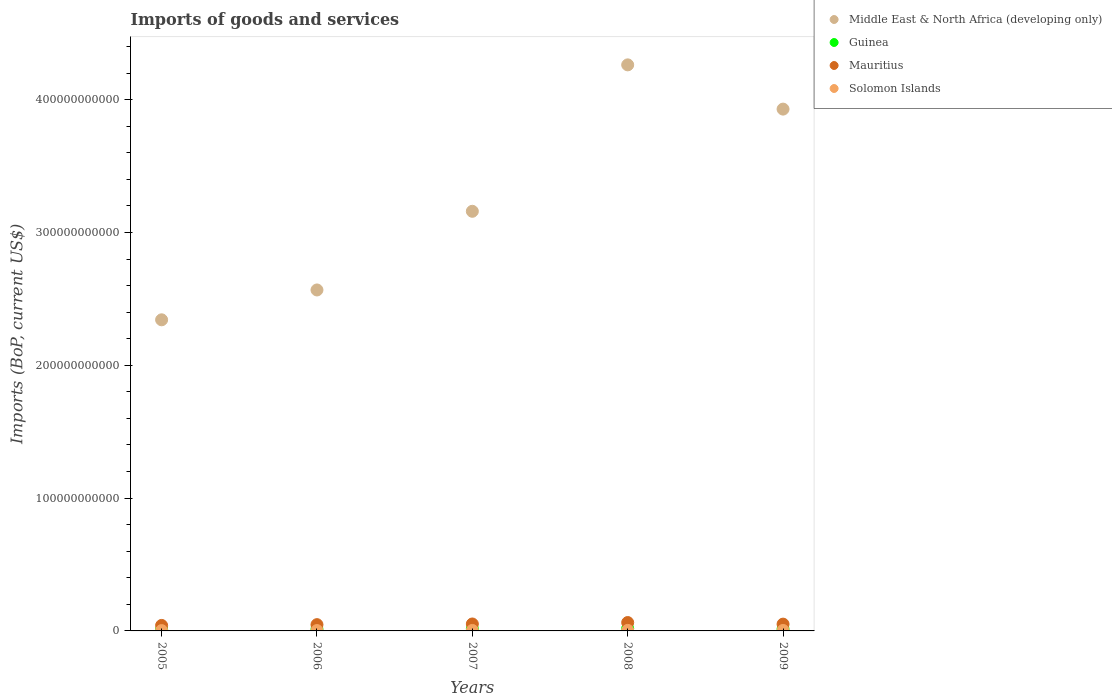How many different coloured dotlines are there?
Your response must be concise. 4. What is the amount spent on imports in Solomon Islands in 2009?
Provide a short and direct response. 3.44e+08. Across all years, what is the maximum amount spent on imports in Mauritius?
Your answer should be compact. 6.31e+09. Across all years, what is the minimum amount spent on imports in Middle East & North Africa (developing only)?
Your response must be concise. 2.34e+11. In which year was the amount spent on imports in Mauritius maximum?
Make the answer very short. 2008. What is the total amount spent on imports in Mauritius in the graph?
Give a very brief answer. 2.55e+1. What is the difference between the amount spent on imports in Guinea in 2005 and that in 2007?
Make the answer very short. -4.85e+08. What is the difference between the amount spent on imports in Mauritius in 2007 and the amount spent on imports in Solomon Islands in 2009?
Your answer should be very brief. 4.88e+09. What is the average amount spent on imports in Solomon Islands per year?
Offer a very short reply. 3.20e+08. In the year 2006, what is the difference between the amount spent on imports in Guinea and amount spent on imports in Solomon Islands?
Provide a succinct answer. 9.93e+08. In how many years, is the amount spent on imports in Mauritius greater than 160000000000 US$?
Keep it short and to the point. 0. What is the ratio of the amount spent on imports in Solomon Islands in 2007 to that in 2008?
Your answer should be compact. 0.91. Is the amount spent on imports in Middle East & North Africa (developing only) in 2006 less than that in 2007?
Give a very brief answer. Yes. What is the difference between the highest and the second highest amount spent on imports in Mauritius?
Make the answer very short. 1.08e+09. What is the difference between the highest and the lowest amount spent on imports in Guinea?
Ensure brevity in your answer.  7.83e+08. In how many years, is the amount spent on imports in Solomon Islands greater than the average amount spent on imports in Solomon Islands taken over all years?
Offer a terse response. 3. Is the sum of the amount spent on imports in Solomon Islands in 2005 and 2007 greater than the maximum amount spent on imports in Middle East & North Africa (developing only) across all years?
Your answer should be very brief. No. Is it the case that in every year, the sum of the amount spent on imports in Mauritius and amount spent on imports in Guinea  is greater than the sum of amount spent on imports in Middle East & North Africa (developing only) and amount spent on imports in Solomon Islands?
Your answer should be very brief. Yes. Does the amount spent on imports in Guinea monotonically increase over the years?
Offer a very short reply. No. How many dotlines are there?
Give a very brief answer. 4. What is the difference between two consecutive major ticks on the Y-axis?
Your answer should be compact. 1.00e+11. Are the values on the major ticks of Y-axis written in scientific E-notation?
Ensure brevity in your answer.  No. Does the graph contain any zero values?
Offer a terse response. No. What is the title of the graph?
Give a very brief answer. Imports of goods and services. What is the label or title of the Y-axis?
Your answer should be compact. Imports (BoP, current US$). What is the Imports (BoP, current US$) of Middle East & North Africa (developing only) in 2005?
Offer a terse response. 2.34e+11. What is the Imports (BoP, current US$) in Guinea in 2005?
Keep it short and to the point. 1.03e+09. What is the Imports (BoP, current US$) in Mauritius in 2005?
Your answer should be very brief. 4.13e+09. What is the Imports (BoP, current US$) of Solomon Islands in 2005?
Provide a succinct answer. 2.43e+08. What is the Imports (BoP, current US$) of Middle East & North Africa (developing only) in 2006?
Keep it short and to the point. 2.57e+11. What is the Imports (BoP, current US$) of Guinea in 2006?
Provide a succinct answer. 1.26e+09. What is the Imports (BoP, current US$) in Mauritius in 2006?
Make the answer very short. 4.73e+09. What is the Imports (BoP, current US$) of Solomon Islands in 2006?
Give a very brief answer. 2.63e+08. What is the Imports (BoP, current US$) of Middle East & North Africa (developing only) in 2007?
Offer a terse response. 3.16e+11. What is the Imports (BoP, current US$) of Guinea in 2007?
Offer a very short reply. 1.51e+09. What is the Imports (BoP, current US$) in Mauritius in 2007?
Provide a short and direct response. 5.23e+09. What is the Imports (BoP, current US$) of Solomon Islands in 2007?
Offer a terse response. 3.58e+08. What is the Imports (BoP, current US$) of Middle East & North Africa (developing only) in 2008?
Your answer should be very brief. 4.26e+11. What is the Imports (BoP, current US$) in Guinea in 2008?
Your answer should be very brief. 1.81e+09. What is the Imports (BoP, current US$) in Mauritius in 2008?
Give a very brief answer. 6.31e+09. What is the Imports (BoP, current US$) of Solomon Islands in 2008?
Make the answer very short. 3.93e+08. What is the Imports (BoP, current US$) in Middle East & North Africa (developing only) in 2009?
Your answer should be compact. 3.93e+11. What is the Imports (BoP, current US$) of Guinea in 2009?
Provide a succinct answer. 1.39e+09. What is the Imports (BoP, current US$) of Mauritius in 2009?
Provide a short and direct response. 5.11e+09. What is the Imports (BoP, current US$) of Solomon Islands in 2009?
Your answer should be very brief. 3.44e+08. Across all years, what is the maximum Imports (BoP, current US$) of Middle East & North Africa (developing only)?
Your response must be concise. 4.26e+11. Across all years, what is the maximum Imports (BoP, current US$) of Guinea?
Keep it short and to the point. 1.81e+09. Across all years, what is the maximum Imports (BoP, current US$) of Mauritius?
Make the answer very short. 6.31e+09. Across all years, what is the maximum Imports (BoP, current US$) of Solomon Islands?
Ensure brevity in your answer.  3.93e+08. Across all years, what is the minimum Imports (BoP, current US$) of Middle East & North Africa (developing only)?
Keep it short and to the point. 2.34e+11. Across all years, what is the minimum Imports (BoP, current US$) in Guinea?
Ensure brevity in your answer.  1.03e+09. Across all years, what is the minimum Imports (BoP, current US$) of Mauritius?
Provide a short and direct response. 4.13e+09. Across all years, what is the minimum Imports (BoP, current US$) of Solomon Islands?
Keep it short and to the point. 2.43e+08. What is the total Imports (BoP, current US$) in Middle East & North Africa (developing only) in the graph?
Keep it short and to the point. 1.63e+12. What is the total Imports (BoP, current US$) in Guinea in the graph?
Offer a terse response. 7.00e+09. What is the total Imports (BoP, current US$) of Mauritius in the graph?
Keep it short and to the point. 2.55e+1. What is the total Imports (BoP, current US$) in Solomon Islands in the graph?
Ensure brevity in your answer.  1.60e+09. What is the difference between the Imports (BoP, current US$) of Middle East & North Africa (developing only) in 2005 and that in 2006?
Your answer should be very brief. -2.25e+1. What is the difference between the Imports (BoP, current US$) in Guinea in 2005 and that in 2006?
Provide a short and direct response. -2.28e+08. What is the difference between the Imports (BoP, current US$) of Mauritius in 2005 and that in 2006?
Provide a short and direct response. -5.93e+08. What is the difference between the Imports (BoP, current US$) of Solomon Islands in 2005 and that in 2006?
Give a very brief answer. -2.03e+07. What is the difference between the Imports (BoP, current US$) of Middle East & North Africa (developing only) in 2005 and that in 2007?
Offer a terse response. -8.17e+1. What is the difference between the Imports (BoP, current US$) in Guinea in 2005 and that in 2007?
Provide a succinct answer. -4.85e+08. What is the difference between the Imports (BoP, current US$) in Mauritius in 2005 and that in 2007?
Ensure brevity in your answer.  -1.09e+09. What is the difference between the Imports (BoP, current US$) of Solomon Islands in 2005 and that in 2007?
Your answer should be very brief. -1.15e+08. What is the difference between the Imports (BoP, current US$) in Middle East & North Africa (developing only) in 2005 and that in 2008?
Give a very brief answer. -1.92e+11. What is the difference between the Imports (BoP, current US$) in Guinea in 2005 and that in 2008?
Provide a short and direct response. -7.83e+08. What is the difference between the Imports (BoP, current US$) in Mauritius in 2005 and that in 2008?
Offer a very short reply. -2.17e+09. What is the difference between the Imports (BoP, current US$) of Solomon Islands in 2005 and that in 2008?
Provide a short and direct response. -1.50e+08. What is the difference between the Imports (BoP, current US$) in Middle East & North Africa (developing only) in 2005 and that in 2009?
Provide a succinct answer. -1.59e+11. What is the difference between the Imports (BoP, current US$) of Guinea in 2005 and that in 2009?
Provide a short and direct response. -3.63e+08. What is the difference between the Imports (BoP, current US$) in Mauritius in 2005 and that in 2009?
Provide a short and direct response. -9.78e+08. What is the difference between the Imports (BoP, current US$) in Solomon Islands in 2005 and that in 2009?
Offer a very short reply. -1.01e+08. What is the difference between the Imports (BoP, current US$) of Middle East & North Africa (developing only) in 2006 and that in 2007?
Provide a succinct answer. -5.92e+1. What is the difference between the Imports (BoP, current US$) in Guinea in 2006 and that in 2007?
Make the answer very short. -2.57e+08. What is the difference between the Imports (BoP, current US$) of Mauritius in 2006 and that in 2007?
Keep it short and to the point. -4.99e+08. What is the difference between the Imports (BoP, current US$) in Solomon Islands in 2006 and that in 2007?
Your answer should be compact. -9.44e+07. What is the difference between the Imports (BoP, current US$) of Middle East & North Africa (developing only) in 2006 and that in 2008?
Keep it short and to the point. -1.69e+11. What is the difference between the Imports (BoP, current US$) of Guinea in 2006 and that in 2008?
Your response must be concise. -5.54e+08. What is the difference between the Imports (BoP, current US$) of Mauritius in 2006 and that in 2008?
Your answer should be compact. -1.58e+09. What is the difference between the Imports (BoP, current US$) of Solomon Islands in 2006 and that in 2008?
Your answer should be compact. -1.29e+08. What is the difference between the Imports (BoP, current US$) of Middle East & North Africa (developing only) in 2006 and that in 2009?
Provide a short and direct response. -1.36e+11. What is the difference between the Imports (BoP, current US$) in Guinea in 2006 and that in 2009?
Offer a terse response. -1.35e+08. What is the difference between the Imports (BoP, current US$) in Mauritius in 2006 and that in 2009?
Give a very brief answer. -3.86e+08. What is the difference between the Imports (BoP, current US$) in Solomon Islands in 2006 and that in 2009?
Your response must be concise. -8.06e+07. What is the difference between the Imports (BoP, current US$) in Middle East & North Africa (developing only) in 2007 and that in 2008?
Your response must be concise. -1.10e+11. What is the difference between the Imports (BoP, current US$) of Guinea in 2007 and that in 2008?
Provide a short and direct response. -2.98e+08. What is the difference between the Imports (BoP, current US$) in Mauritius in 2007 and that in 2008?
Your answer should be compact. -1.08e+09. What is the difference between the Imports (BoP, current US$) of Solomon Islands in 2007 and that in 2008?
Give a very brief answer. -3.50e+07. What is the difference between the Imports (BoP, current US$) of Middle East & North Africa (developing only) in 2007 and that in 2009?
Keep it short and to the point. -7.69e+1. What is the difference between the Imports (BoP, current US$) of Guinea in 2007 and that in 2009?
Make the answer very short. 1.22e+08. What is the difference between the Imports (BoP, current US$) in Mauritius in 2007 and that in 2009?
Offer a very short reply. 1.14e+08. What is the difference between the Imports (BoP, current US$) in Solomon Islands in 2007 and that in 2009?
Ensure brevity in your answer.  1.37e+07. What is the difference between the Imports (BoP, current US$) in Middle East & North Africa (developing only) in 2008 and that in 2009?
Give a very brief answer. 3.33e+1. What is the difference between the Imports (BoP, current US$) of Guinea in 2008 and that in 2009?
Make the answer very short. 4.20e+08. What is the difference between the Imports (BoP, current US$) of Mauritius in 2008 and that in 2009?
Ensure brevity in your answer.  1.19e+09. What is the difference between the Imports (BoP, current US$) in Solomon Islands in 2008 and that in 2009?
Ensure brevity in your answer.  4.87e+07. What is the difference between the Imports (BoP, current US$) of Middle East & North Africa (developing only) in 2005 and the Imports (BoP, current US$) of Guinea in 2006?
Give a very brief answer. 2.33e+11. What is the difference between the Imports (BoP, current US$) of Middle East & North Africa (developing only) in 2005 and the Imports (BoP, current US$) of Mauritius in 2006?
Keep it short and to the point. 2.30e+11. What is the difference between the Imports (BoP, current US$) in Middle East & North Africa (developing only) in 2005 and the Imports (BoP, current US$) in Solomon Islands in 2006?
Your answer should be compact. 2.34e+11. What is the difference between the Imports (BoP, current US$) in Guinea in 2005 and the Imports (BoP, current US$) in Mauritius in 2006?
Your answer should be compact. -3.70e+09. What is the difference between the Imports (BoP, current US$) of Guinea in 2005 and the Imports (BoP, current US$) of Solomon Islands in 2006?
Your answer should be compact. 7.64e+08. What is the difference between the Imports (BoP, current US$) in Mauritius in 2005 and the Imports (BoP, current US$) in Solomon Islands in 2006?
Provide a short and direct response. 3.87e+09. What is the difference between the Imports (BoP, current US$) of Middle East & North Africa (developing only) in 2005 and the Imports (BoP, current US$) of Guinea in 2007?
Your answer should be compact. 2.33e+11. What is the difference between the Imports (BoP, current US$) in Middle East & North Africa (developing only) in 2005 and the Imports (BoP, current US$) in Mauritius in 2007?
Provide a short and direct response. 2.29e+11. What is the difference between the Imports (BoP, current US$) in Middle East & North Africa (developing only) in 2005 and the Imports (BoP, current US$) in Solomon Islands in 2007?
Provide a short and direct response. 2.34e+11. What is the difference between the Imports (BoP, current US$) in Guinea in 2005 and the Imports (BoP, current US$) in Mauritius in 2007?
Give a very brief answer. -4.20e+09. What is the difference between the Imports (BoP, current US$) of Guinea in 2005 and the Imports (BoP, current US$) of Solomon Islands in 2007?
Make the answer very short. 6.70e+08. What is the difference between the Imports (BoP, current US$) in Mauritius in 2005 and the Imports (BoP, current US$) in Solomon Islands in 2007?
Give a very brief answer. 3.78e+09. What is the difference between the Imports (BoP, current US$) in Middle East & North Africa (developing only) in 2005 and the Imports (BoP, current US$) in Guinea in 2008?
Offer a very short reply. 2.32e+11. What is the difference between the Imports (BoP, current US$) of Middle East & North Africa (developing only) in 2005 and the Imports (BoP, current US$) of Mauritius in 2008?
Give a very brief answer. 2.28e+11. What is the difference between the Imports (BoP, current US$) of Middle East & North Africa (developing only) in 2005 and the Imports (BoP, current US$) of Solomon Islands in 2008?
Ensure brevity in your answer.  2.34e+11. What is the difference between the Imports (BoP, current US$) in Guinea in 2005 and the Imports (BoP, current US$) in Mauritius in 2008?
Your answer should be compact. -5.28e+09. What is the difference between the Imports (BoP, current US$) of Guinea in 2005 and the Imports (BoP, current US$) of Solomon Islands in 2008?
Make the answer very short. 6.35e+08. What is the difference between the Imports (BoP, current US$) in Mauritius in 2005 and the Imports (BoP, current US$) in Solomon Islands in 2008?
Give a very brief answer. 3.74e+09. What is the difference between the Imports (BoP, current US$) of Middle East & North Africa (developing only) in 2005 and the Imports (BoP, current US$) of Guinea in 2009?
Your answer should be compact. 2.33e+11. What is the difference between the Imports (BoP, current US$) in Middle East & North Africa (developing only) in 2005 and the Imports (BoP, current US$) in Mauritius in 2009?
Your response must be concise. 2.29e+11. What is the difference between the Imports (BoP, current US$) of Middle East & North Africa (developing only) in 2005 and the Imports (BoP, current US$) of Solomon Islands in 2009?
Your answer should be compact. 2.34e+11. What is the difference between the Imports (BoP, current US$) in Guinea in 2005 and the Imports (BoP, current US$) in Mauritius in 2009?
Your answer should be compact. -4.08e+09. What is the difference between the Imports (BoP, current US$) of Guinea in 2005 and the Imports (BoP, current US$) of Solomon Islands in 2009?
Keep it short and to the point. 6.84e+08. What is the difference between the Imports (BoP, current US$) in Mauritius in 2005 and the Imports (BoP, current US$) in Solomon Islands in 2009?
Your answer should be compact. 3.79e+09. What is the difference between the Imports (BoP, current US$) in Middle East & North Africa (developing only) in 2006 and the Imports (BoP, current US$) in Guinea in 2007?
Provide a succinct answer. 2.55e+11. What is the difference between the Imports (BoP, current US$) of Middle East & North Africa (developing only) in 2006 and the Imports (BoP, current US$) of Mauritius in 2007?
Your answer should be very brief. 2.52e+11. What is the difference between the Imports (BoP, current US$) of Middle East & North Africa (developing only) in 2006 and the Imports (BoP, current US$) of Solomon Islands in 2007?
Offer a very short reply. 2.56e+11. What is the difference between the Imports (BoP, current US$) of Guinea in 2006 and the Imports (BoP, current US$) of Mauritius in 2007?
Keep it short and to the point. -3.97e+09. What is the difference between the Imports (BoP, current US$) in Guinea in 2006 and the Imports (BoP, current US$) in Solomon Islands in 2007?
Provide a succinct answer. 8.98e+08. What is the difference between the Imports (BoP, current US$) in Mauritius in 2006 and the Imports (BoP, current US$) in Solomon Islands in 2007?
Your answer should be very brief. 4.37e+09. What is the difference between the Imports (BoP, current US$) of Middle East & North Africa (developing only) in 2006 and the Imports (BoP, current US$) of Guinea in 2008?
Make the answer very short. 2.55e+11. What is the difference between the Imports (BoP, current US$) in Middle East & North Africa (developing only) in 2006 and the Imports (BoP, current US$) in Mauritius in 2008?
Your answer should be compact. 2.50e+11. What is the difference between the Imports (BoP, current US$) of Middle East & North Africa (developing only) in 2006 and the Imports (BoP, current US$) of Solomon Islands in 2008?
Offer a very short reply. 2.56e+11. What is the difference between the Imports (BoP, current US$) of Guinea in 2006 and the Imports (BoP, current US$) of Mauritius in 2008?
Keep it short and to the point. -5.05e+09. What is the difference between the Imports (BoP, current US$) of Guinea in 2006 and the Imports (BoP, current US$) of Solomon Islands in 2008?
Provide a succinct answer. 8.63e+08. What is the difference between the Imports (BoP, current US$) in Mauritius in 2006 and the Imports (BoP, current US$) in Solomon Islands in 2008?
Make the answer very short. 4.33e+09. What is the difference between the Imports (BoP, current US$) of Middle East & North Africa (developing only) in 2006 and the Imports (BoP, current US$) of Guinea in 2009?
Keep it short and to the point. 2.55e+11. What is the difference between the Imports (BoP, current US$) in Middle East & North Africa (developing only) in 2006 and the Imports (BoP, current US$) in Mauritius in 2009?
Your answer should be compact. 2.52e+11. What is the difference between the Imports (BoP, current US$) in Middle East & North Africa (developing only) in 2006 and the Imports (BoP, current US$) in Solomon Islands in 2009?
Make the answer very short. 2.56e+11. What is the difference between the Imports (BoP, current US$) in Guinea in 2006 and the Imports (BoP, current US$) in Mauritius in 2009?
Provide a succinct answer. -3.86e+09. What is the difference between the Imports (BoP, current US$) in Guinea in 2006 and the Imports (BoP, current US$) in Solomon Islands in 2009?
Give a very brief answer. 9.12e+08. What is the difference between the Imports (BoP, current US$) in Mauritius in 2006 and the Imports (BoP, current US$) in Solomon Islands in 2009?
Provide a succinct answer. 4.38e+09. What is the difference between the Imports (BoP, current US$) in Middle East & North Africa (developing only) in 2007 and the Imports (BoP, current US$) in Guinea in 2008?
Offer a very short reply. 3.14e+11. What is the difference between the Imports (BoP, current US$) of Middle East & North Africa (developing only) in 2007 and the Imports (BoP, current US$) of Mauritius in 2008?
Provide a succinct answer. 3.10e+11. What is the difference between the Imports (BoP, current US$) of Middle East & North Africa (developing only) in 2007 and the Imports (BoP, current US$) of Solomon Islands in 2008?
Provide a succinct answer. 3.16e+11. What is the difference between the Imports (BoP, current US$) of Guinea in 2007 and the Imports (BoP, current US$) of Mauritius in 2008?
Make the answer very short. -4.79e+09. What is the difference between the Imports (BoP, current US$) in Guinea in 2007 and the Imports (BoP, current US$) in Solomon Islands in 2008?
Provide a short and direct response. 1.12e+09. What is the difference between the Imports (BoP, current US$) in Mauritius in 2007 and the Imports (BoP, current US$) in Solomon Islands in 2008?
Make the answer very short. 4.83e+09. What is the difference between the Imports (BoP, current US$) in Middle East & North Africa (developing only) in 2007 and the Imports (BoP, current US$) in Guinea in 2009?
Your answer should be very brief. 3.15e+11. What is the difference between the Imports (BoP, current US$) in Middle East & North Africa (developing only) in 2007 and the Imports (BoP, current US$) in Mauritius in 2009?
Provide a short and direct response. 3.11e+11. What is the difference between the Imports (BoP, current US$) of Middle East & North Africa (developing only) in 2007 and the Imports (BoP, current US$) of Solomon Islands in 2009?
Your answer should be very brief. 3.16e+11. What is the difference between the Imports (BoP, current US$) in Guinea in 2007 and the Imports (BoP, current US$) in Mauritius in 2009?
Your answer should be very brief. -3.60e+09. What is the difference between the Imports (BoP, current US$) in Guinea in 2007 and the Imports (BoP, current US$) in Solomon Islands in 2009?
Your answer should be compact. 1.17e+09. What is the difference between the Imports (BoP, current US$) in Mauritius in 2007 and the Imports (BoP, current US$) in Solomon Islands in 2009?
Make the answer very short. 4.88e+09. What is the difference between the Imports (BoP, current US$) of Middle East & North Africa (developing only) in 2008 and the Imports (BoP, current US$) of Guinea in 2009?
Provide a short and direct response. 4.25e+11. What is the difference between the Imports (BoP, current US$) in Middle East & North Africa (developing only) in 2008 and the Imports (BoP, current US$) in Mauritius in 2009?
Ensure brevity in your answer.  4.21e+11. What is the difference between the Imports (BoP, current US$) of Middle East & North Africa (developing only) in 2008 and the Imports (BoP, current US$) of Solomon Islands in 2009?
Your answer should be very brief. 4.26e+11. What is the difference between the Imports (BoP, current US$) in Guinea in 2008 and the Imports (BoP, current US$) in Mauritius in 2009?
Give a very brief answer. -3.30e+09. What is the difference between the Imports (BoP, current US$) of Guinea in 2008 and the Imports (BoP, current US$) of Solomon Islands in 2009?
Your response must be concise. 1.47e+09. What is the difference between the Imports (BoP, current US$) in Mauritius in 2008 and the Imports (BoP, current US$) in Solomon Islands in 2009?
Keep it short and to the point. 5.96e+09. What is the average Imports (BoP, current US$) of Middle East & North Africa (developing only) per year?
Offer a very short reply. 3.25e+11. What is the average Imports (BoP, current US$) of Guinea per year?
Make the answer very short. 1.40e+09. What is the average Imports (BoP, current US$) in Mauritius per year?
Give a very brief answer. 5.10e+09. What is the average Imports (BoP, current US$) of Solomon Islands per year?
Ensure brevity in your answer.  3.20e+08. In the year 2005, what is the difference between the Imports (BoP, current US$) of Middle East & North Africa (developing only) and Imports (BoP, current US$) of Guinea?
Your response must be concise. 2.33e+11. In the year 2005, what is the difference between the Imports (BoP, current US$) in Middle East & North Africa (developing only) and Imports (BoP, current US$) in Mauritius?
Offer a very short reply. 2.30e+11. In the year 2005, what is the difference between the Imports (BoP, current US$) of Middle East & North Africa (developing only) and Imports (BoP, current US$) of Solomon Islands?
Keep it short and to the point. 2.34e+11. In the year 2005, what is the difference between the Imports (BoP, current US$) of Guinea and Imports (BoP, current US$) of Mauritius?
Your response must be concise. -3.11e+09. In the year 2005, what is the difference between the Imports (BoP, current US$) in Guinea and Imports (BoP, current US$) in Solomon Islands?
Your answer should be compact. 7.84e+08. In the year 2005, what is the difference between the Imports (BoP, current US$) in Mauritius and Imports (BoP, current US$) in Solomon Islands?
Make the answer very short. 3.89e+09. In the year 2006, what is the difference between the Imports (BoP, current US$) of Middle East & North Africa (developing only) and Imports (BoP, current US$) of Guinea?
Your answer should be very brief. 2.55e+11. In the year 2006, what is the difference between the Imports (BoP, current US$) in Middle East & North Africa (developing only) and Imports (BoP, current US$) in Mauritius?
Your answer should be compact. 2.52e+11. In the year 2006, what is the difference between the Imports (BoP, current US$) of Middle East & North Africa (developing only) and Imports (BoP, current US$) of Solomon Islands?
Offer a terse response. 2.56e+11. In the year 2006, what is the difference between the Imports (BoP, current US$) of Guinea and Imports (BoP, current US$) of Mauritius?
Your response must be concise. -3.47e+09. In the year 2006, what is the difference between the Imports (BoP, current US$) in Guinea and Imports (BoP, current US$) in Solomon Islands?
Your answer should be very brief. 9.93e+08. In the year 2006, what is the difference between the Imports (BoP, current US$) of Mauritius and Imports (BoP, current US$) of Solomon Islands?
Your answer should be very brief. 4.46e+09. In the year 2007, what is the difference between the Imports (BoP, current US$) in Middle East & North Africa (developing only) and Imports (BoP, current US$) in Guinea?
Ensure brevity in your answer.  3.14e+11. In the year 2007, what is the difference between the Imports (BoP, current US$) of Middle East & North Africa (developing only) and Imports (BoP, current US$) of Mauritius?
Give a very brief answer. 3.11e+11. In the year 2007, what is the difference between the Imports (BoP, current US$) of Middle East & North Africa (developing only) and Imports (BoP, current US$) of Solomon Islands?
Provide a short and direct response. 3.16e+11. In the year 2007, what is the difference between the Imports (BoP, current US$) in Guinea and Imports (BoP, current US$) in Mauritius?
Provide a succinct answer. -3.71e+09. In the year 2007, what is the difference between the Imports (BoP, current US$) in Guinea and Imports (BoP, current US$) in Solomon Islands?
Your answer should be compact. 1.15e+09. In the year 2007, what is the difference between the Imports (BoP, current US$) in Mauritius and Imports (BoP, current US$) in Solomon Islands?
Your response must be concise. 4.87e+09. In the year 2008, what is the difference between the Imports (BoP, current US$) of Middle East & North Africa (developing only) and Imports (BoP, current US$) of Guinea?
Your answer should be very brief. 4.24e+11. In the year 2008, what is the difference between the Imports (BoP, current US$) of Middle East & North Africa (developing only) and Imports (BoP, current US$) of Mauritius?
Your answer should be compact. 4.20e+11. In the year 2008, what is the difference between the Imports (BoP, current US$) of Middle East & North Africa (developing only) and Imports (BoP, current US$) of Solomon Islands?
Offer a terse response. 4.26e+11. In the year 2008, what is the difference between the Imports (BoP, current US$) of Guinea and Imports (BoP, current US$) of Mauritius?
Offer a terse response. -4.50e+09. In the year 2008, what is the difference between the Imports (BoP, current US$) in Guinea and Imports (BoP, current US$) in Solomon Islands?
Make the answer very short. 1.42e+09. In the year 2008, what is the difference between the Imports (BoP, current US$) of Mauritius and Imports (BoP, current US$) of Solomon Islands?
Ensure brevity in your answer.  5.91e+09. In the year 2009, what is the difference between the Imports (BoP, current US$) of Middle East & North Africa (developing only) and Imports (BoP, current US$) of Guinea?
Your answer should be compact. 3.92e+11. In the year 2009, what is the difference between the Imports (BoP, current US$) of Middle East & North Africa (developing only) and Imports (BoP, current US$) of Mauritius?
Give a very brief answer. 3.88e+11. In the year 2009, what is the difference between the Imports (BoP, current US$) of Middle East & North Africa (developing only) and Imports (BoP, current US$) of Solomon Islands?
Provide a succinct answer. 3.93e+11. In the year 2009, what is the difference between the Imports (BoP, current US$) of Guinea and Imports (BoP, current US$) of Mauritius?
Keep it short and to the point. -3.72e+09. In the year 2009, what is the difference between the Imports (BoP, current US$) in Guinea and Imports (BoP, current US$) in Solomon Islands?
Make the answer very short. 1.05e+09. In the year 2009, what is the difference between the Imports (BoP, current US$) of Mauritius and Imports (BoP, current US$) of Solomon Islands?
Make the answer very short. 4.77e+09. What is the ratio of the Imports (BoP, current US$) in Middle East & North Africa (developing only) in 2005 to that in 2006?
Give a very brief answer. 0.91. What is the ratio of the Imports (BoP, current US$) of Guinea in 2005 to that in 2006?
Provide a short and direct response. 0.82. What is the ratio of the Imports (BoP, current US$) of Mauritius in 2005 to that in 2006?
Your answer should be very brief. 0.87. What is the ratio of the Imports (BoP, current US$) in Solomon Islands in 2005 to that in 2006?
Keep it short and to the point. 0.92. What is the ratio of the Imports (BoP, current US$) in Middle East & North Africa (developing only) in 2005 to that in 2007?
Offer a terse response. 0.74. What is the ratio of the Imports (BoP, current US$) in Guinea in 2005 to that in 2007?
Ensure brevity in your answer.  0.68. What is the ratio of the Imports (BoP, current US$) of Mauritius in 2005 to that in 2007?
Your answer should be compact. 0.79. What is the ratio of the Imports (BoP, current US$) of Solomon Islands in 2005 to that in 2007?
Give a very brief answer. 0.68. What is the ratio of the Imports (BoP, current US$) in Middle East & North Africa (developing only) in 2005 to that in 2008?
Offer a terse response. 0.55. What is the ratio of the Imports (BoP, current US$) in Guinea in 2005 to that in 2008?
Give a very brief answer. 0.57. What is the ratio of the Imports (BoP, current US$) in Mauritius in 2005 to that in 2008?
Your answer should be very brief. 0.66. What is the ratio of the Imports (BoP, current US$) in Solomon Islands in 2005 to that in 2008?
Offer a very short reply. 0.62. What is the ratio of the Imports (BoP, current US$) of Middle East & North Africa (developing only) in 2005 to that in 2009?
Offer a very short reply. 0.6. What is the ratio of the Imports (BoP, current US$) of Guinea in 2005 to that in 2009?
Provide a succinct answer. 0.74. What is the ratio of the Imports (BoP, current US$) in Mauritius in 2005 to that in 2009?
Provide a short and direct response. 0.81. What is the ratio of the Imports (BoP, current US$) in Solomon Islands in 2005 to that in 2009?
Offer a terse response. 0.71. What is the ratio of the Imports (BoP, current US$) of Middle East & North Africa (developing only) in 2006 to that in 2007?
Provide a short and direct response. 0.81. What is the ratio of the Imports (BoP, current US$) of Guinea in 2006 to that in 2007?
Provide a short and direct response. 0.83. What is the ratio of the Imports (BoP, current US$) in Mauritius in 2006 to that in 2007?
Offer a terse response. 0.9. What is the ratio of the Imports (BoP, current US$) of Solomon Islands in 2006 to that in 2007?
Your answer should be compact. 0.74. What is the ratio of the Imports (BoP, current US$) of Middle East & North Africa (developing only) in 2006 to that in 2008?
Offer a very short reply. 0.6. What is the ratio of the Imports (BoP, current US$) of Guinea in 2006 to that in 2008?
Offer a very short reply. 0.69. What is the ratio of the Imports (BoP, current US$) of Mauritius in 2006 to that in 2008?
Keep it short and to the point. 0.75. What is the ratio of the Imports (BoP, current US$) of Solomon Islands in 2006 to that in 2008?
Offer a very short reply. 0.67. What is the ratio of the Imports (BoP, current US$) of Middle East & North Africa (developing only) in 2006 to that in 2009?
Your response must be concise. 0.65. What is the ratio of the Imports (BoP, current US$) of Guinea in 2006 to that in 2009?
Offer a very short reply. 0.9. What is the ratio of the Imports (BoP, current US$) in Mauritius in 2006 to that in 2009?
Your response must be concise. 0.92. What is the ratio of the Imports (BoP, current US$) of Solomon Islands in 2006 to that in 2009?
Offer a very short reply. 0.77. What is the ratio of the Imports (BoP, current US$) in Middle East & North Africa (developing only) in 2007 to that in 2008?
Your answer should be very brief. 0.74. What is the ratio of the Imports (BoP, current US$) of Guinea in 2007 to that in 2008?
Give a very brief answer. 0.84. What is the ratio of the Imports (BoP, current US$) in Mauritius in 2007 to that in 2008?
Give a very brief answer. 0.83. What is the ratio of the Imports (BoP, current US$) in Solomon Islands in 2007 to that in 2008?
Keep it short and to the point. 0.91. What is the ratio of the Imports (BoP, current US$) in Middle East & North Africa (developing only) in 2007 to that in 2009?
Give a very brief answer. 0.8. What is the ratio of the Imports (BoP, current US$) in Guinea in 2007 to that in 2009?
Make the answer very short. 1.09. What is the ratio of the Imports (BoP, current US$) in Mauritius in 2007 to that in 2009?
Ensure brevity in your answer.  1.02. What is the ratio of the Imports (BoP, current US$) in Middle East & North Africa (developing only) in 2008 to that in 2009?
Make the answer very short. 1.08. What is the ratio of the Imports (BoP, current US$) of Guinea in 2008 to that in 2009?
Make the answer very short. 1.3. What is the ratio of the Imports (BoP, current US$) in Mauritius in 2008 to that in 2009?
Your response must be concise. 1.23. What is the ratio of the Imports (BoP, current US$) in Solomon Islands in 2008 to that in 2009?
Ensure brevity in your answer.  1.14. What is the difference between the highest and the second highest Imports (BoP, current US$) in Middle East & North Africa (developing only)?
Provide a short and direct response. 3.33e+1. What is the difference between the highest and the second highest Imports (BoP, current US$) in Guinea?
Keep it short and to the point. 2.98e+08. What is the difference between the highest and the second highest Imports (BoP, current US$) in Mauritius?
Ensure brevity in your answer.  1.08e+09. What is the difference between the highest and the second highest Imports (BoP, current US$) in Solomon Islands?
Your response must be concise. 3.50e+07. What is the difference between the highest and the lowest Imports (BoP, current US$) in Middle East & North Africa (developing only)?
Your response must be concise. 1.92e+11. What is the difference between the highest and the lowest Imports (BoP, current US$) in Guinea?
Provide a short and direct response. 7.83e+08. What is the difference between the highest and the lowest Imports (BoP, current US$) in Mauritius?
Offer a very short reply. 2.17e+09. What is the difference between the highest and the lowest Imports (BoP, current US$) in Solomon Islands?
Your response must be concise. 1.50e+08. 